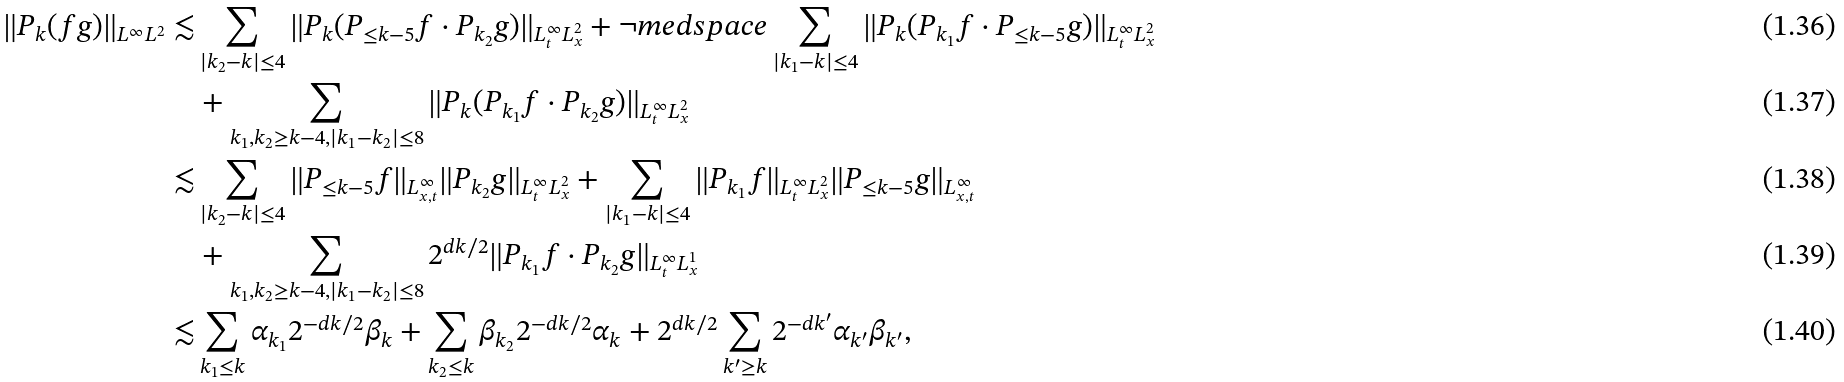Convert formula to latex. <formula><loc_0><loc_0><loc_500><loc_500>\| P _ { k } ( f g ) \| _ { L ^ { \infty } L ^ { 2 } } \lesssim & \sum _ { | k _ { 2 } - k | \leq 4 } \| P _ { k } ( P _ { \leq k - 5 } f \cdot P _ { k _ { 2 } } g ) \| _ { L ^ { \infty } _ { t } L ^ { 2 } _ { x } } + \neg m e d s p a c e \sum _ { | k _ { 1 } - k | \leq 4 } \| P _ { k } ( P _ { k _ { 1 } } f \cdot P _ { \leq k - 5 } g ) \| _ { L ^ { \infty } _ { t } L ^ { 2 } _ { x } } \\ & + \sum _ { k _ { 1 } , k _ { 2 } \geq k - 4 , | k _ { 1 } - k _ { 2 } | \leq 8 } \| P _ { k } ( P _ { k _ { 1 } } f \cdot P _ { k _ { 2 } } g ) \| _ { L ^ { \infty } _ { t } L ^ { 2 } _ { x } } \\ \lesssim & \sum _ { | k _ { 2 } - k | \leq 4 } \| P _ { \leq k - 5 } f \| _ { L ^ { \infty } _ { x , t } } \| P _ { k _ { 2 } } g \| _ { L ^ { \infty } _ { t } L ^ { 2 } _ { x } } + \sum _ { | k _ { 1 } - k | \leq 4 } \| P _ { k _ { 1 } } f \| _ { L ^ { \infty } _ { t } L ^ { 2 } _ { x } } \| P _ { \leq k - 5 } g \| _ { L ^ { \infty } _ { x , t } } \\ & + \sum _ { k _ { 1 } , k _ { 2 } \geq k - 4 , | k _ { 1 } - k _ { 2 } | \leq 8 } 2 ^ { d k / 2 } \| P _ { k _ { 1 } } f \cdot P _ { k _ { 2 } } g \| _ { L ^ { \infty } _ { t } L ^ { 1 } _ { x } } \\ \lesssim & \sum _ { k _ { 1 } \leq k } \alpha _ { k _ { 1 } } 2 ^ { - d k / 2 } \beta _ { k } + \sum _ { k _ { 2 } \leq k } \beta _ { k _ { 2 } } 2 ^ { - d k / 2 } \alpha _ { k } + 2 ^ { d k / 2 } \sum _ { k ^ { \prime } \geq k } 2 ^ { - d k ^ { \prime } } \alpha _ { k ^ { \prime } } \beta _ { k ^ { \prime } } ,</formula> 